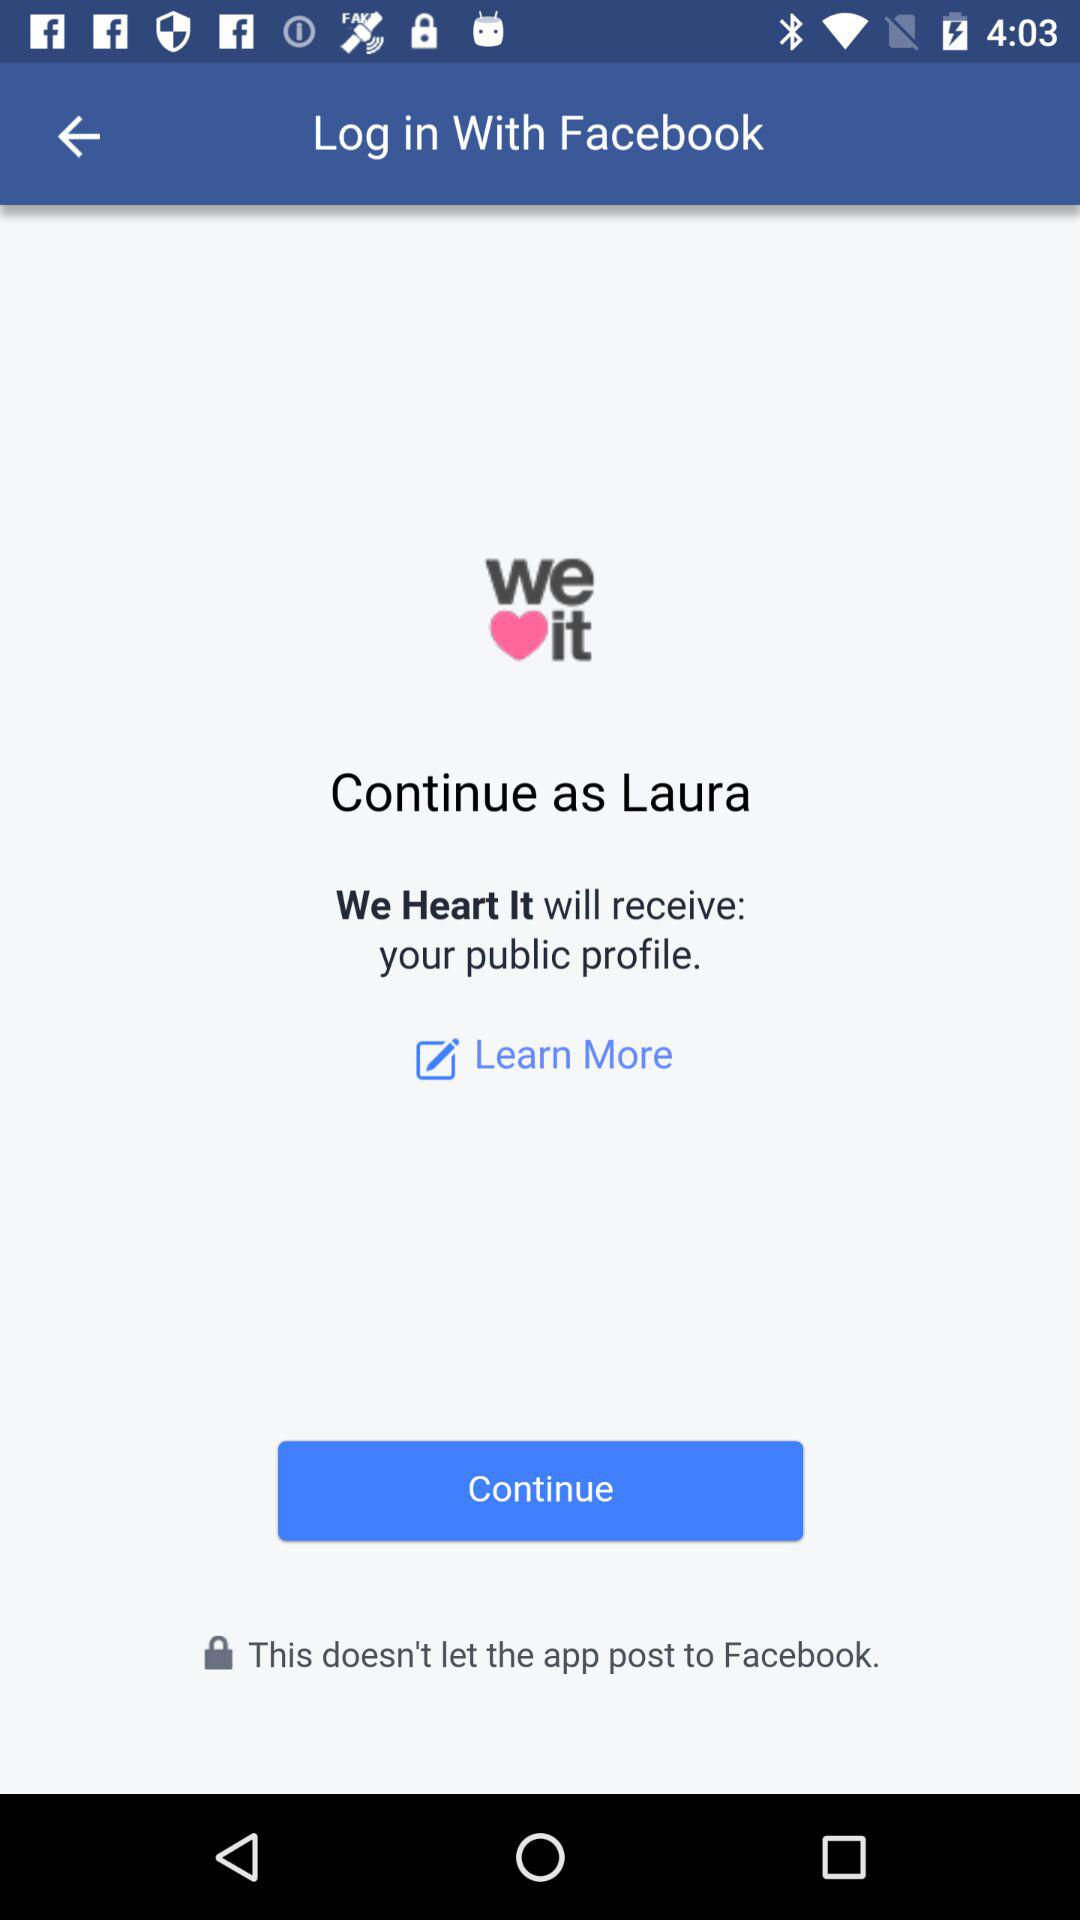What is the user name? The user name is "Laura". 